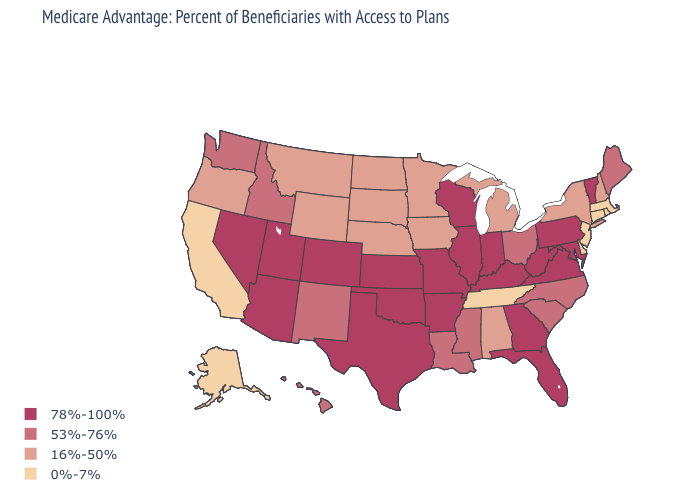Does the first symbol in the legend represent the smallest category?
Concise answer only. No. Does Delaware have the lowest value in the USA?
Write a very short answer. Yes. Which states have the highest value in the USA?
Keep it brief. Arkansas, Arizona, Colorado, Florida, Georgia, Illinois, Indiana, Kansas, Kentucky, Maryland, Missouri, Nevada, Oklahoma, Pennsylvania, Texas, Utah, Virginia, Vermont, Wisconsin, West Virginia. Which states hav the highest value in the West?
Give a very brief answer. Arizona, Colorado, Nevada, Utah. Which states hav the highest value in the MidWest?
Quick response, please. Illinois, Indiana, Kansas, Missouri, Wisconsin. Name the states that have a value in the range 53%-76%?
Answer briefly. Hawaii, Idaho, Louisiana, Maine, Mississippi, North Carolina, New Mexico, Ohio, South Carolina, Washington. Name the states that have a value in the range 53%-76%?
Short answer required. Hawaii, Idaho, Louisiana, Maine, Mississippi, North Carolina, New Mexico, Ohio, South Carolina, Washington. Does Pennsylvania have the highest value in the USA?
Be succinct. Yes. What is the lowest value in the South?
Write a very short answer. 0%-7%. Among the states that border Idaho , which have the highest value?
Write a very short answer. Nevada, Utah. What is the highest value in the Northeast ?
Quick response, please. 78%-100%. Name the states that have a value in the range 0%-7%?
Concise answer only. Alaska, California, Connecticut, Delaware, Massachusetts, New Jersey, Rhode Island, Tennessee. Name the states that have a value in the range 0%-7%?
Give a very brief answer. Alaska, California, Connecticut, Delaware, Massachusetts, New Jersey, Rhode Island, Tennessee. Does Rhode Island have the same value as Nebraska?
Answer briefly. No. Name the states that have a value in the range 16%-50%?
Quick response, please. Alabama, Iowa, Michigan, Minnesota, Montana, North Dakota, Nebraska, New Hampshire, New York, Oregon, South Dakota, Wyoming. 